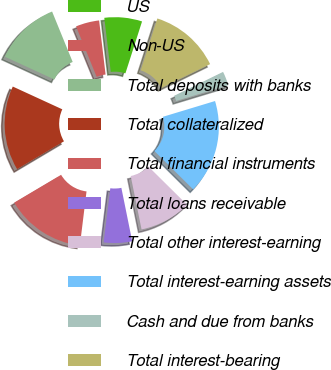<chart> <loc_0><loc_0><loc_500><loc_500><pie_chart><fcel>US<fcel>Non-US<fcel>Total deposits with banks<fcel>Total collateralized<fcel>Total financial instruments<fcel>Total loans receivable<fcel>Total other interest-earning<fcel>Total interest-earning assets<fcel>Cash and due from banks<fcel>Total interest-bearing<nl><fcel>6.84%<fcel>4.27%<fcel>11.97%<fcel>15.38%<fcel>14.53%<fcel>5.13%<fcel>9.4%<fcel>17.09%<fcel>2.56%<fcel>12.82%<nl></chart> 